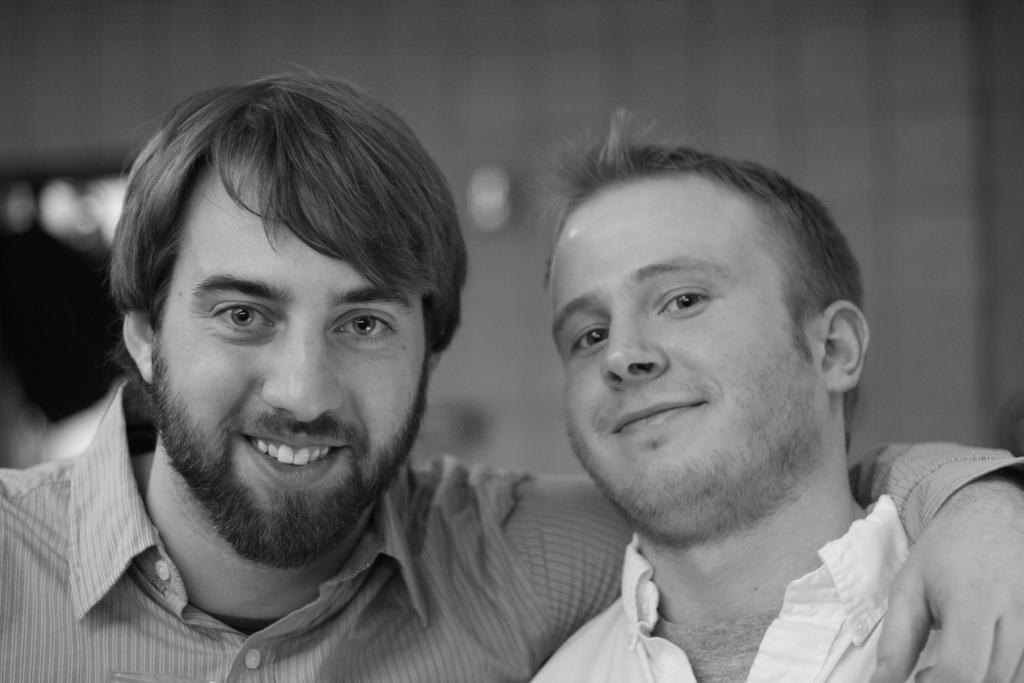How many people are in the image? There are two people in the image. What expressions do the people have in the image? Both people are smiling in the image. What type of secretary is present in the image? There is no secretary present in the image; it only features two people who are smiling. 